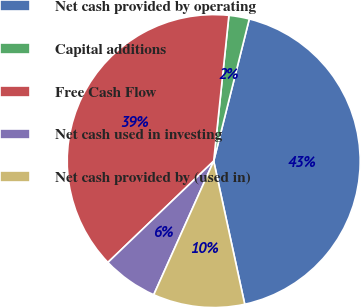Convert chart to OTSL. <chart><loc_0><loc_0><loc_500><loc_500><pie_chart><fcel>Net cash provided by operating<fcel>Capital additions<fcel>Free Cash Flow<fcel>Net cash used in investing<fcel>Net cash provided by (used in)<nl><fcel>42.7%<fcel>2.25%<fcel>38.82%<fcel>6.13%<fcel>10.11%<nl></chart> 